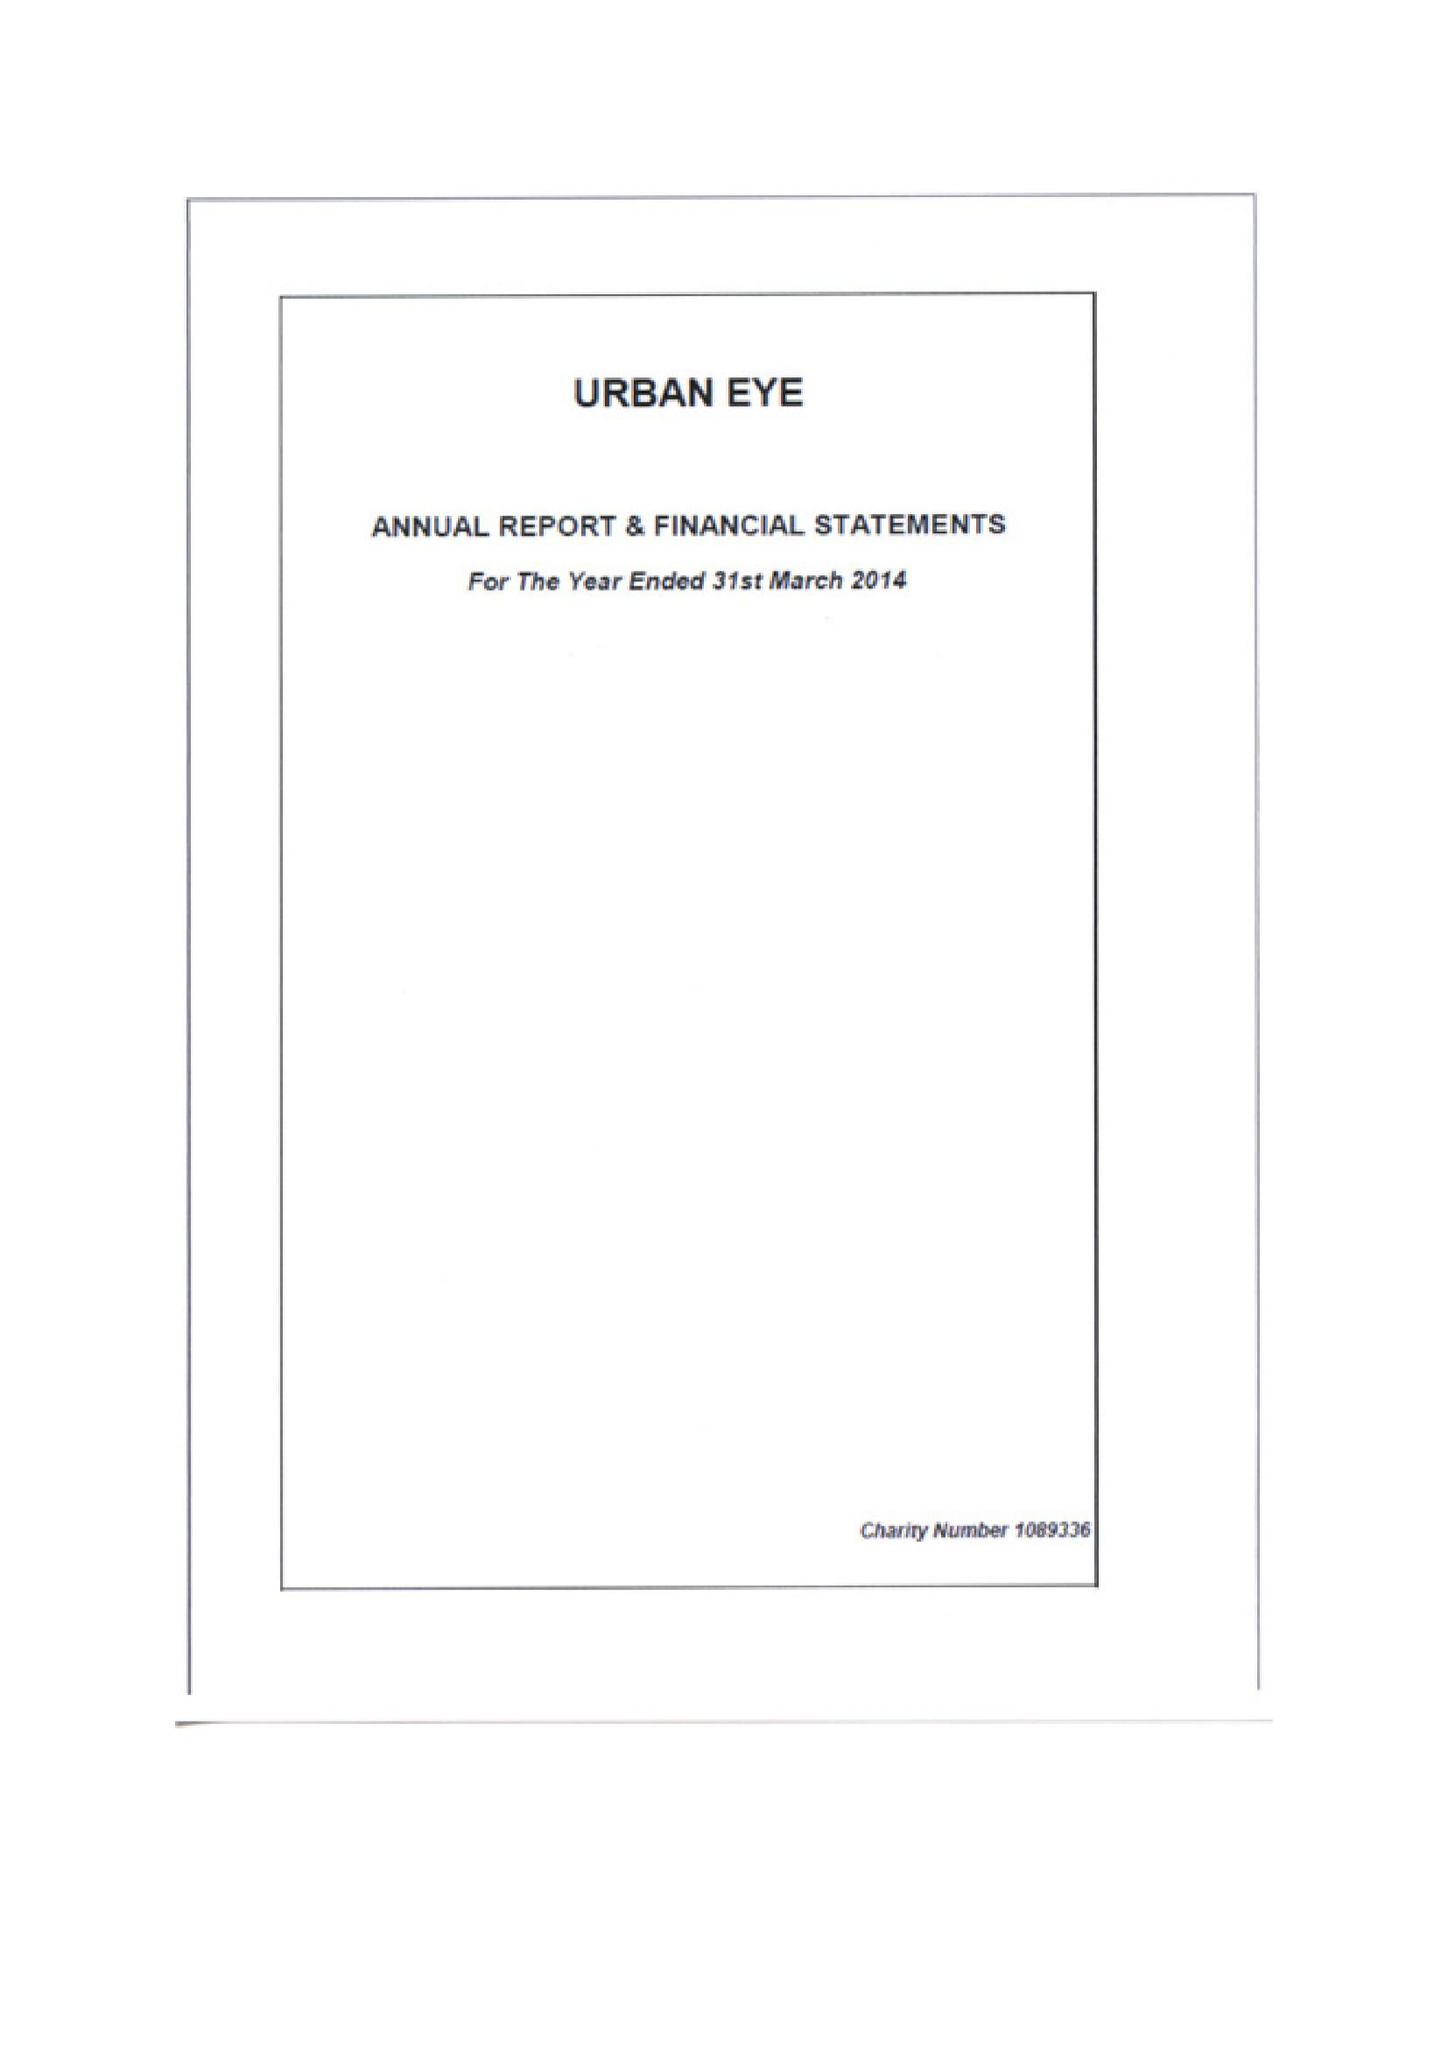What is the value for the report_date?
Answer the question using a single word or phrase. 2014-03-31 